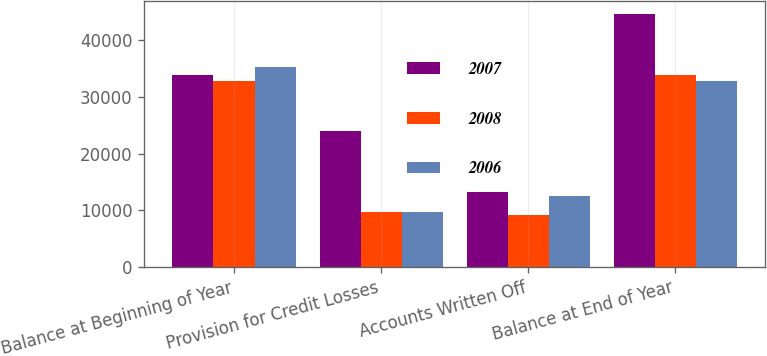Convert chart. <chart><loc_0><loc_0><loc_500><loc_500><stacked_bar_chart><ecel><fcel>Balance at Beginning of Year<fcel>Provision for Credit Losses<fcel>Accounts Written Off<fcel>Balance at End of Year<nl><fcel>2007<fcel>33810<fcel>24037<fcel>13197<fcel>44650<nl><fcel>2008<fcel>32817<fcel>9672<fcel>9174<fcel>33810<nl><fcel>2006<fcel>35239<fcel>9730<fcel>12473<fcel>32817<nl></chart> 